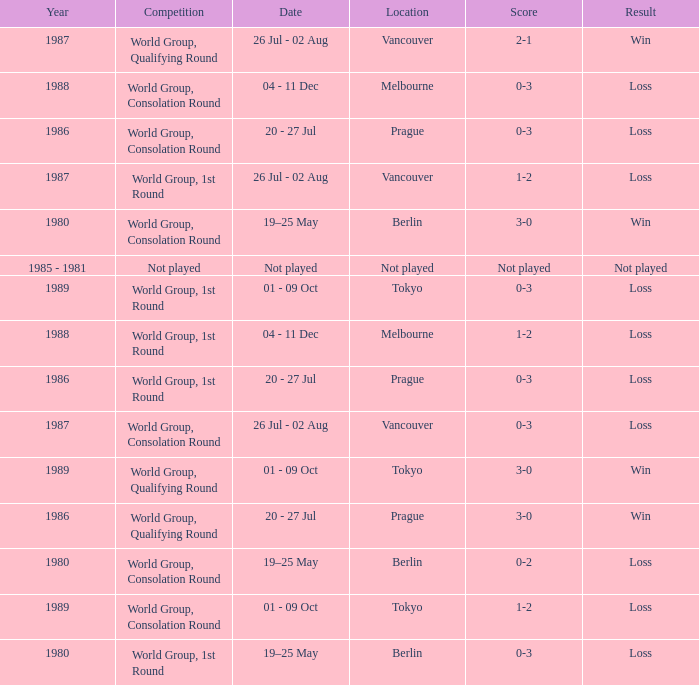What is the year when the date is not played? 1985 - 1981. 